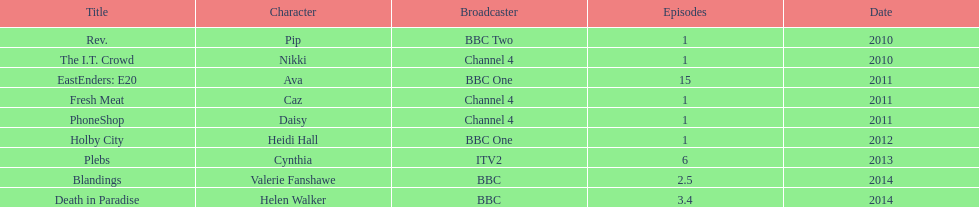Could you parse the entire table as a dict? {'header': ['Title', 'Character', 'Broadcaster', 'Episodes', 'Date'], 'rows': [['Rev.', 'Pip', 'BBC Two', '1', '2010'], ['The I.T. Crowd', 'Nikki', 'Channel 4', '1', '2010'], ['EastEnders: E20', 'Ava', 'BBC One', '15', '2011'], ['Fresh Meat', 'Caz', 'Channel 4', '1', '2011'], ['PhoneShop', 'Daisy', 'Channel 4', '1', '2011'], ['Holby City', 'Heidi Hall', 'BBC One', '1', '2012'], ['Plebs', 'Cynthia', 'ITV2', '6', '2013'], ['Blandings', 'Valerie Fanshawe', 'BBC', '2.5', '2014'], ['Death in Paradise', 'Helen Walker', 'BBC', '3.4', '2014']]} In how many titles are there 5 or more episodes? 2. 